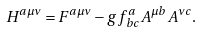<formula> <loc_0><loc_0><loc_500><loc_500>H ^ { a \mu \nu } = F ^ { a \mu \nu } - g f _ { \, b c } ^ { a } A ^ { \mu b } A ^ { \nu c } .</formula> 